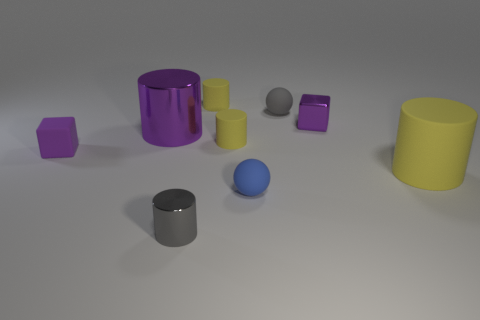Subtract all cyan blocks. How many yellow cylinders are left? 3 Subtract all purple cylinders. How many cylinders are left? 4 Subtract all small gray cylinders. How many cylinders are left? 4 Subtract all cyan cylinders. Subtract all blue cubes. How many cylinders are left? 5 Subtract all cylinders. How many objects are left? 4 Subtract 0 yellow balls. How many objects are left? 9 Subtract all rubber things. Subtract all matte cylinders. How many objects are left? 0 Add 8 gray spheres. How many gray spheres are left? 9 Add 2 yellow matte cylinders. How many yellow matte cylinders exist? 5 